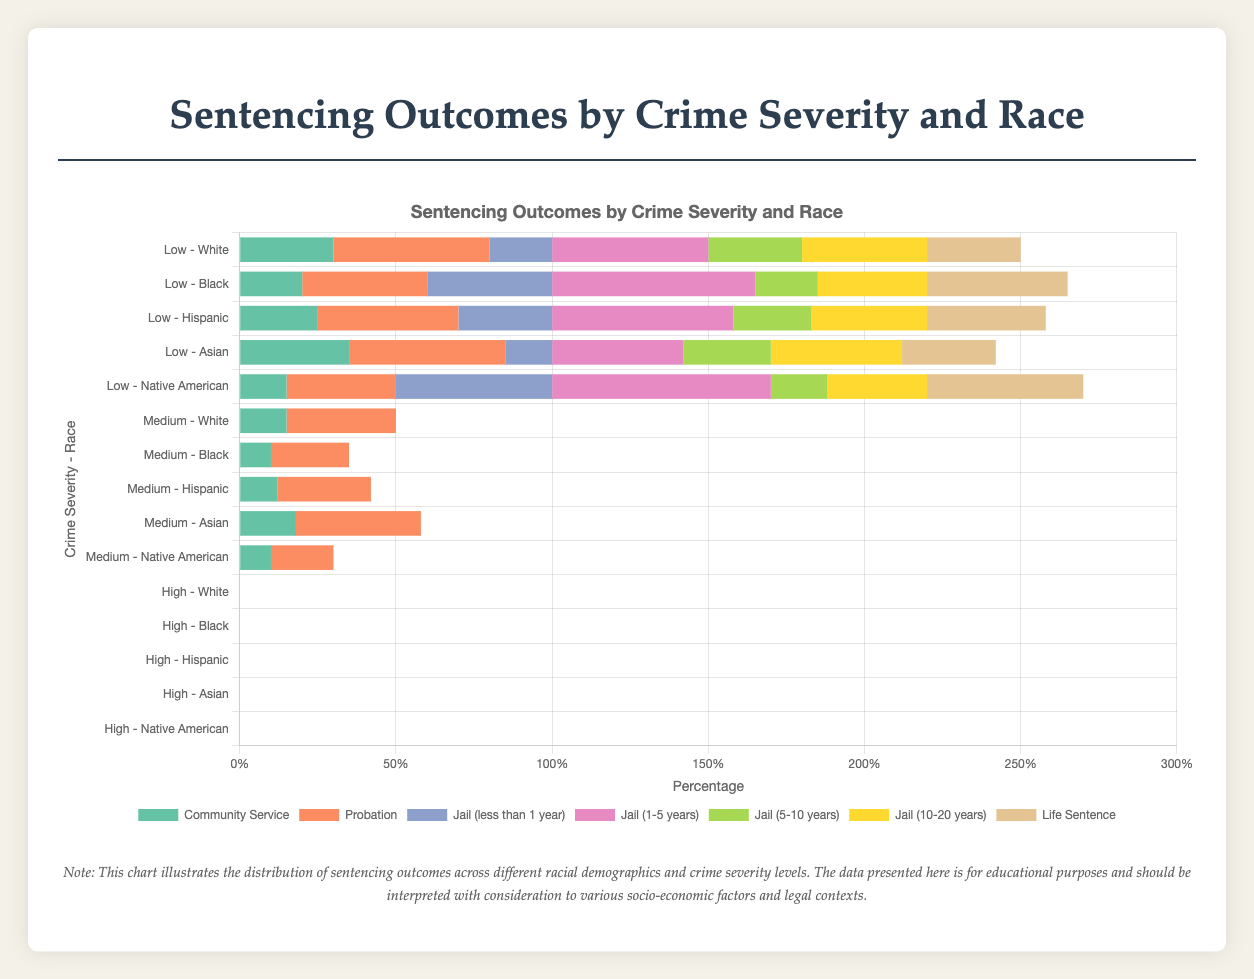Which racial group has the highest percentage of community service for low severity crimes? We need to compare the community service percentages for each racial group for low severity crimes. White has 30%, Black has 20%, Hispanic has 25%, Asian has 35%, and Native American has 15%. The highest percentage is for Asians at 35%.
Answer: Asian Compare the percentage of Black and Hispanic individuals receiving life sentences for high severity crimes. Look at the life sentences for high severity crimes for Black (45%) and Hispanic (38%) individuals. Compare these values directly to see that 45% is greater than 38%.
Answer: Black What is the difference in the percentage of jail sentences (5-10 years) between White and Native American individuals for high severity crimes? Check the percentages for jail sentences (5-10 years) for Whites and Native Americans in high severity crimes: White has 30%, and Native American has 18%. Calculate the difference: 30% - 18% = 12%.
Answer: 12% Which demographic has the lowest percentage of probation for medium severity crimes? Compare the probation percentages for medium severity crimes across all demographics: White (35%), Black (25%), Hispanic (30%), Asian (40%), Native American (20%). Native American has the lowest percentage at 20%.
Answer: Native American What is the total percentage of sentences involving jail (less than 1 year) for low severity crimes across all racial groups? Sum the percentages of jail sentences (less than 1 year) for low severity crimes for all racial groups: White (20%), Black (40%), Hispanic (30%), Asian (15%), Native American (50%). The total is 20% + 40% + 30% + 15% + 50% = 155%.
Answer: 155% Between Asian and Hispanic individuals, which group has a higher percentage of jail sentences (1-5 years) for medium severity crimes and by how much? Compare jail sentences (1-5 years) percentages for medium severity crimes between Asian (42%) and Hispanic (58%) individuals. Hispanic has a higher percentage by 58% - 42% = 16%.
Answer: Hispanic by 16% For low severity crimes, what is the average percentage of individuals receiving probation across all racial groups? Sum the probation percentages for low severity crimes across all racial groups: White (50%), Black (40%), Hispanic (45%), Asian (50%), Native American (35%). Calculate the average: (50% + 40% + 45% + 50% + 35%) / 5 = 44%.
Answer: 44% What is the percentage difference in life sentences between Hispanic and Native American individuals for high severity crimes? Compare the life sentences percentages for high severity crimes: Hispanic (38%), Native American (50%). Calculate the percentage difference: 50% - 38% = 12%.
Answer: 12% 